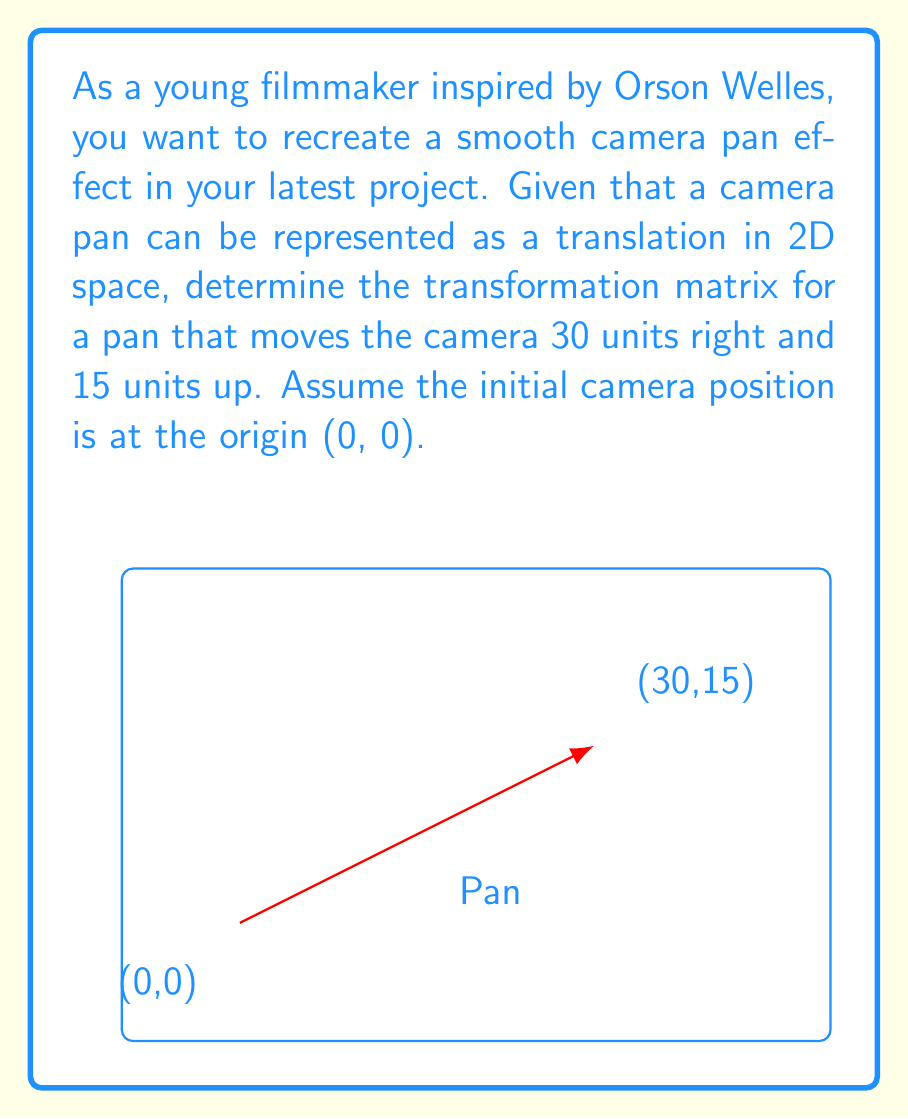Show me your answer to this math problem. Let's approach this step-by-step:

1) A camera pan is essentially a translation in 2D space. The general form of a 2D translation matrix is:

   $$T = \begin{bmatrix}
   1 & 0 & t_x \\
   0 & 1 & t_y \\
   0 & 0 & 1
   \end{bmatrix}$$

   Where $t_x$ is the translation along the x-axis and $t_y$ is the translation along the y-axis.

2) In this case, we're moving:
   - 30 units right (positive x-direction), so $t_x = 30$
   - 15 units up (positive y-direction), so $t_y = 15$

3) Substituting these values into our general translation matrix:

   $$T = \begin{bmatrix}
   1 & 0 & 30 \\
   0 & 1 & 15 \\
   0 & 0 & 1
   \end{bmatrix}$$

4) This matrix, when applied to any point $(x, y)$ in homogeneous coordinates $(x, y, 1)$, will translate it by 30 units right and 15 units up.

5) For example, applying this to the initial camera position (0, 0):

   $$\begin{bmatrix}
   1 & 0 & 30 \\
   0 & 1 & 15 \\
   0 & 0 & 1
   \end{bmatrix}
   \begin{bmatrix}
   0 \\
   0 \\
   1
   \end{bmatrix}
   =
   \begin{bmatrix}
   30 \\
   15 \\
   1
   \end{bmatrix}$$

   This confirms that the camera has moved to (30, 15) as required.
Answer: $$T = \begin{bmatrix}
1 & 0 & 30 \\
0 & 1 & 15 \\
0 & 0 & 1
\end{bmatrix}$$ 